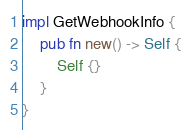<code> <loc_0><loc_0><loc_500><loc_500><_Rust_>
impl GetWebhookInfo {
    pub fn new() -> Self {
        Self {}
    }
}
</code> 